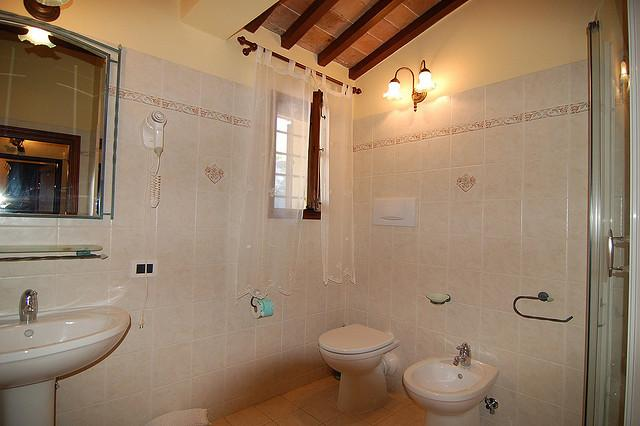How many places could an animal get water from here? three 